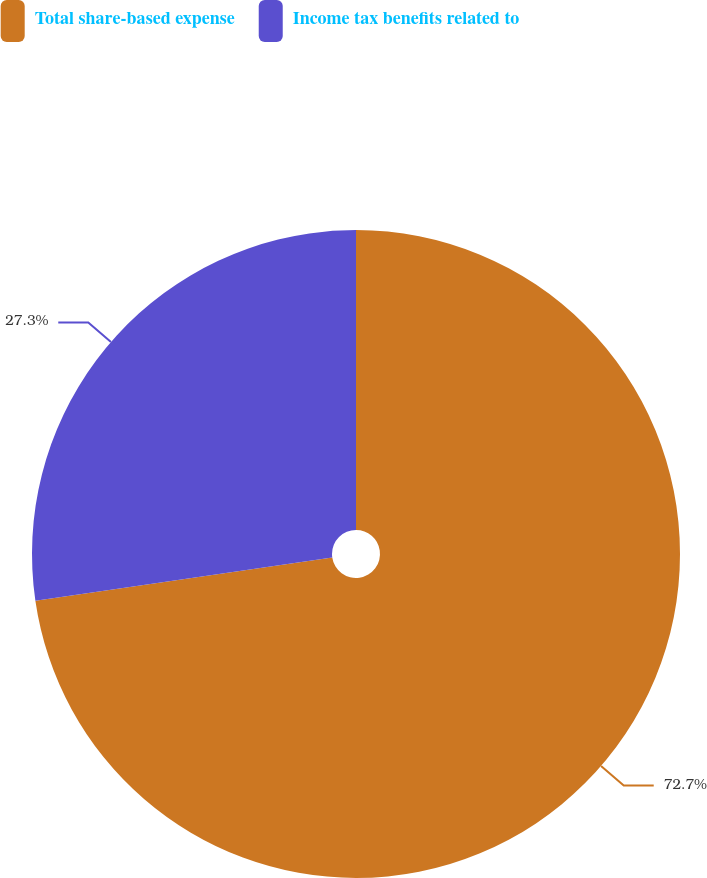Convert chart. <chart><loc_0><loc_0><loc_500><loc_500><pie_chart><fcel>Total share-based expense<fcel>Income tax benefits related to<nl><fcel>72.7%<fcel>27.3%<nl></chart> 